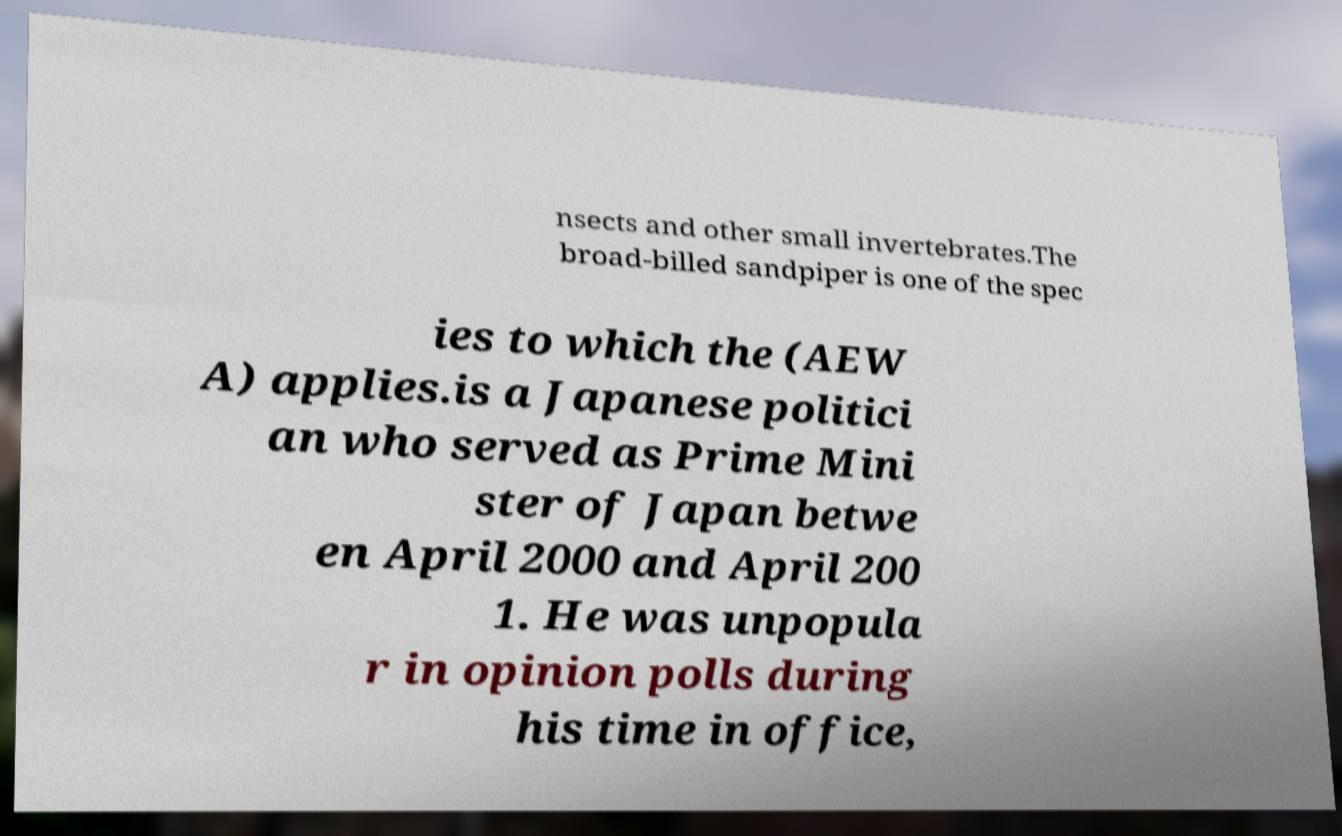What messages or text are displayed in this image? I need them in a readable, typed format. nsects and other small invertebrates.The broad-billed sandpiper is one of the spec ies to which the (AEW A) applies.is a Japanese politici an who served as Prime Mini ster of Japan betwe en April 2000 and April 200 1. He was unpopula r in opinion polls during his time in office, 